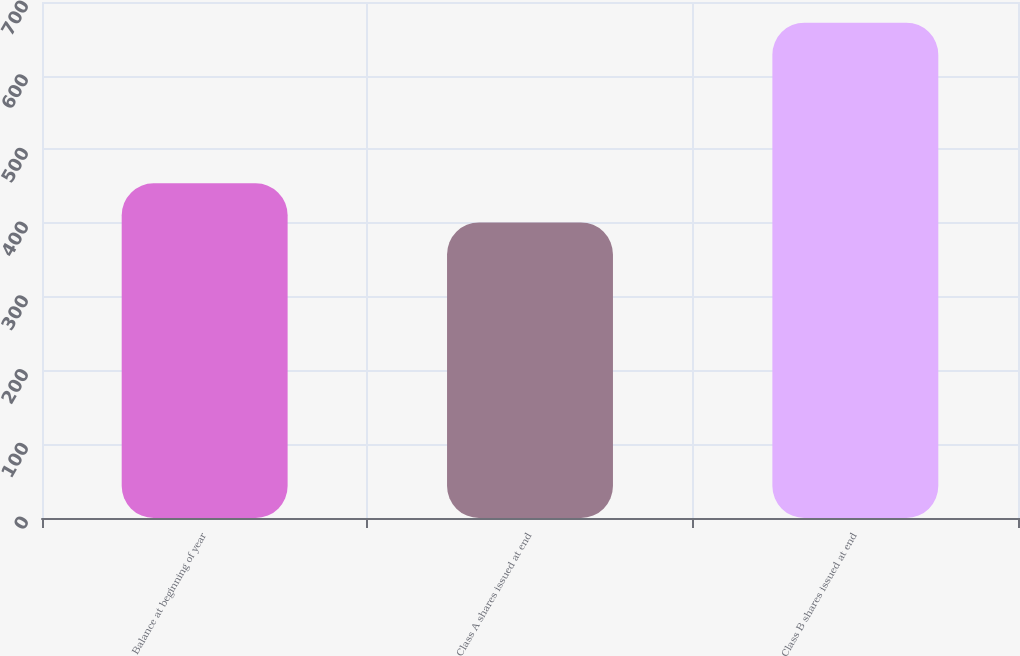Convert chart to OTSL. <chart><loc_0><loc_0><loc_500><loc_500><bar_chart><fcel>Balance at beginning of year<fcel>Class A shares issued at end<fcel>Class B shares issued at end<nl><fcel>454<fcel>401<fcel>672<nl></chart> 